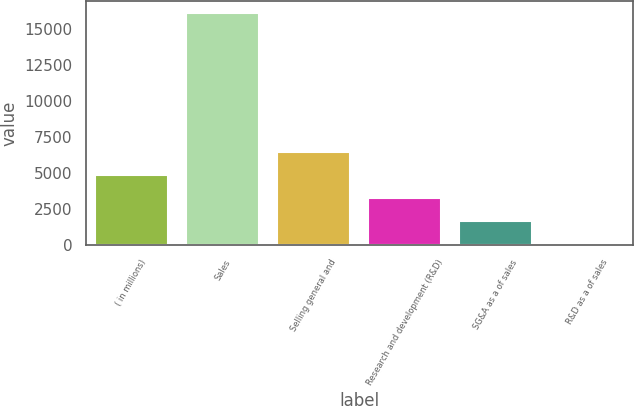Convert chart. <chart><loc_0><loc_0><loc_500><loc_500><bar_chart><fcel>( in millions)<fcel>Sales<fcel>Selling general and<fcel>Research and development (R&D)<fcel>SG&A as a of sales<fcel>R&D as a of sales<nl><fcel>4831.56<fcel>16090.5<fcel>6439.98<fcel>3223.14<fcel>1614.72<fcel>6.3<nl></chart> 